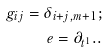Convert formula to latex. <formula><loc_0><loc_0><loc_500><loc_500>g _ { i j } = \delta _ { i + j , m + 1 } ; \\ e = \partial _ { t ^ { 1 } } . .</formula> 